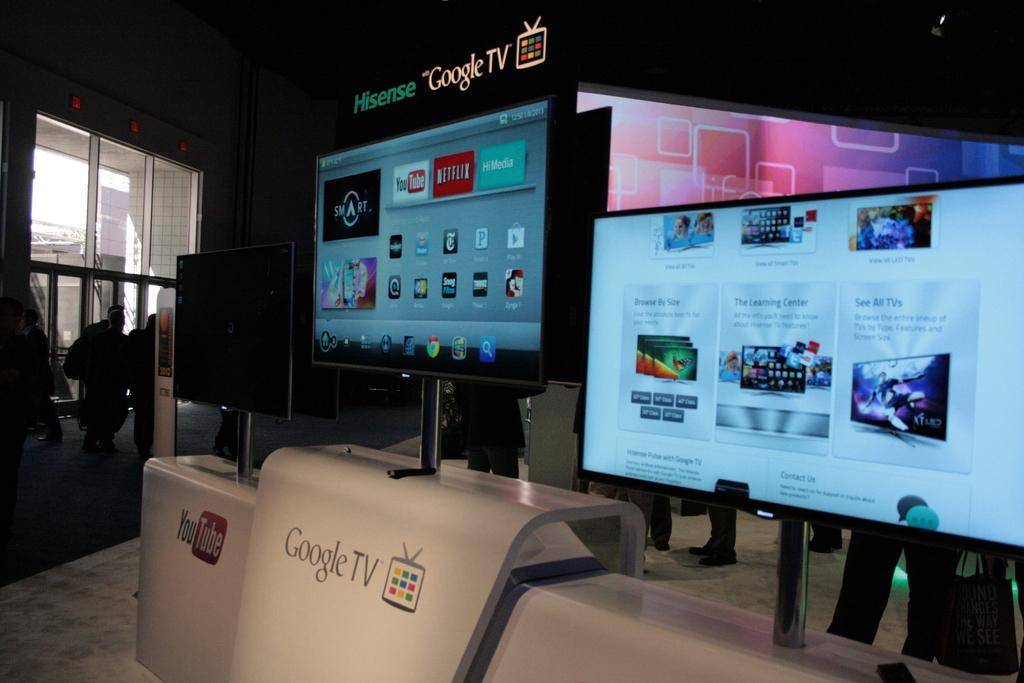Provide a one-sentence caption for the provided image. Three screens are displayed horizontally sitting on stands to display ads for youtube and google. 